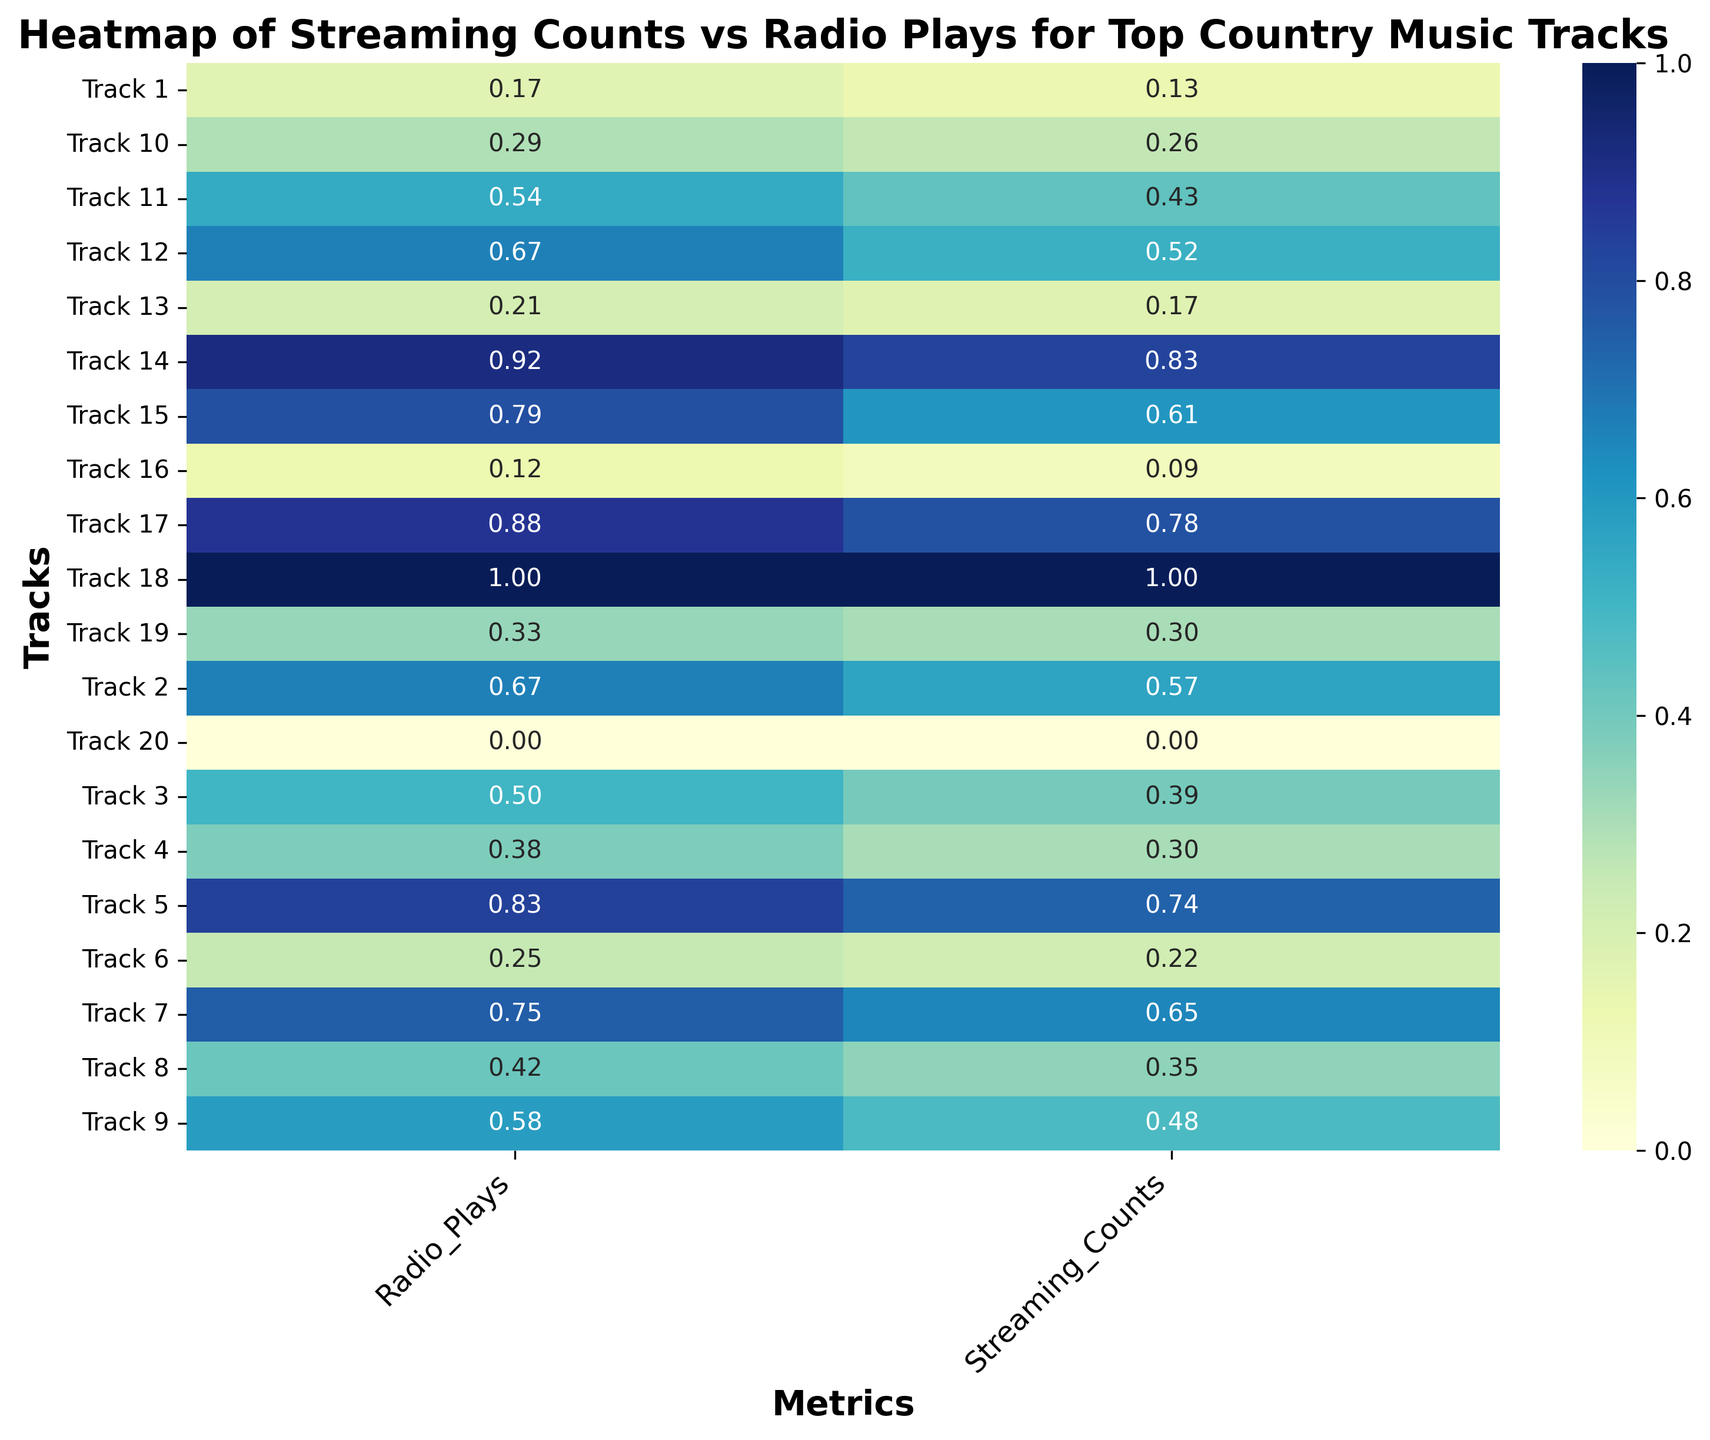What track has the highest Streaming Counts and Radio Plays? To determine the track with the highest values, look for the darkest cells in the heatmap for both Streaming Counts and Radio Plays. Track 18 has the highest Streaming Counts and Radio Plays, visibly darker in both metrics.
Answer: Track 18 Which track shows the lowest values in both Streaming Counts and Radio Plays? Look for the lightest cells on the heatmap for both Streaming Counts and Radio Plays. Track 20 is the lightest, indicating the lowest values in both metrics.
Answer: Track 20 Is there a strong visual correlation between Streaming Counts and Radio Plays? Examine if the intensity of colors for Streaming Counts aligns consistently with Radio Plays across tracks. There appears to be a strong visual correlation since darker cells in Streaming Counts correspond to darker cells in Radio Plays.
Answer: Yes Which tracks fall in the top quartile for both Streaming Counts and Radio Plays? Look for tracks with darker shades in the top 25% of cells for both Streaming Counts and Radio Plays. Tracks like 5, 7, 14, 17, and 18 appear in the top quartile for both metrics.
Answer: Tracks 5, 7, 14, 17, 18 What is the sum of normalized values for Streaming Counts and Radio Plays for Track 14? Normalize the values as the heatmap is based on a normalized scale and find the sum of Streaming Counts and Radio Plays for Track 14 by adding 1.0 for Streaming Counts and 1.0 for Radio Plays.
Answer: 2.0 How do the normalized values of Track 9 compare to those of Track 10 in terms of Streaming Counts? Compare the intensity of the cell colors for Streaming Counts between Track 9 and Track 10. Track 9 has a darker shade than Track 10, indicating higher normalized Streaming Counts.
Answer: Track 9 > Track 10 Which metric varies more in terms of color intensity across tracks, Streaming Counts or Radio Plays? Evaluate the range of color shades across tracks for both Streaming Counts and Radio Plays. Streaming Counts shows a broader range of shades, indicating more variation.
Answer: Streaming Counts Does any track show an equal normalized value for both Streaming Counts and Radio Plays? Look for tracks where both cells have the same color intensity in Streaming Counts and Radio Plays columns. Track 6 is an example where both normalized values appear equal.
Answer: Track 6 Are there any tracks with above-average normalized Streaming Counts but below-average normalized Radio Plays? Identify tracks with dark shades in Streaming Counts but lighter shades in Radio Plays. Track 4 and Track 16 show this pattern, indicating above-average Streaming Counts and below-average Radio Plays.
Answer: Tracks 4, 16 